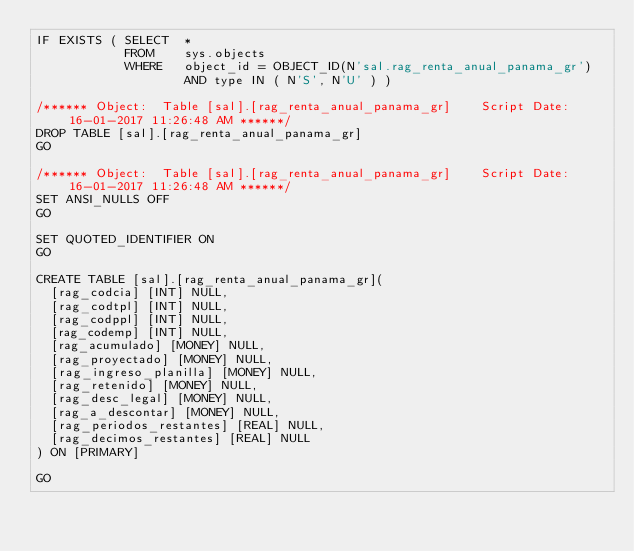<code> <loc_0><loc_0><loc_500><loc_500><_SQL_>IF EXISTS ( SELECT  *
            FROM    sys.objects
            WHERE   object_id = OBJECT_ID(N'sal.rag_renta_anual_panama_gr')
                    AND type IN ( N'S', N'U' ) )

/****** Object:  Table [sal].[rag_renta_anual_panama_gr]    Script Date: 16-01-2017 11:26:48 AM ******/
DROP TABLE [sal].[rag_renta_anual_panama_gr]
GO

/****** Object:  Table [sal].[rag_renta_anual_panama_gr]    Script Date: 16-01-2017 11:26:48 AM ******/
SET ANSI_NULLS OFF
GO

SET QUOTED_IDENTIFIER ON
GO

CREATE TABLE [sal].[rag_renta_anual_panama_gr](
	[rag_codcia] [INT] NULL,
	[rag_codtpl] [INT] NULL,
	[rag_codppl] [INT] NULL,
	[rag_codemp] [INT] NULL,
	[rag_acumulado] [MONEY] NULL,
	[rag_proyectado] [MONEY] NULL,
	[rag_ingreso_planilla] [MONEY] NULL,
	[rag_retenido] [MONEY] NULL,
	[rag_desc_legal] [MONEY] NULL,
	[rag_a_descontar] [MONEY] NULL,
	[rag_periodos_restantes] [REAL] NULL,
	[rag_decimos_restantes] [REAL] NULL
) ON [PRIMARY]

GO


</code> 